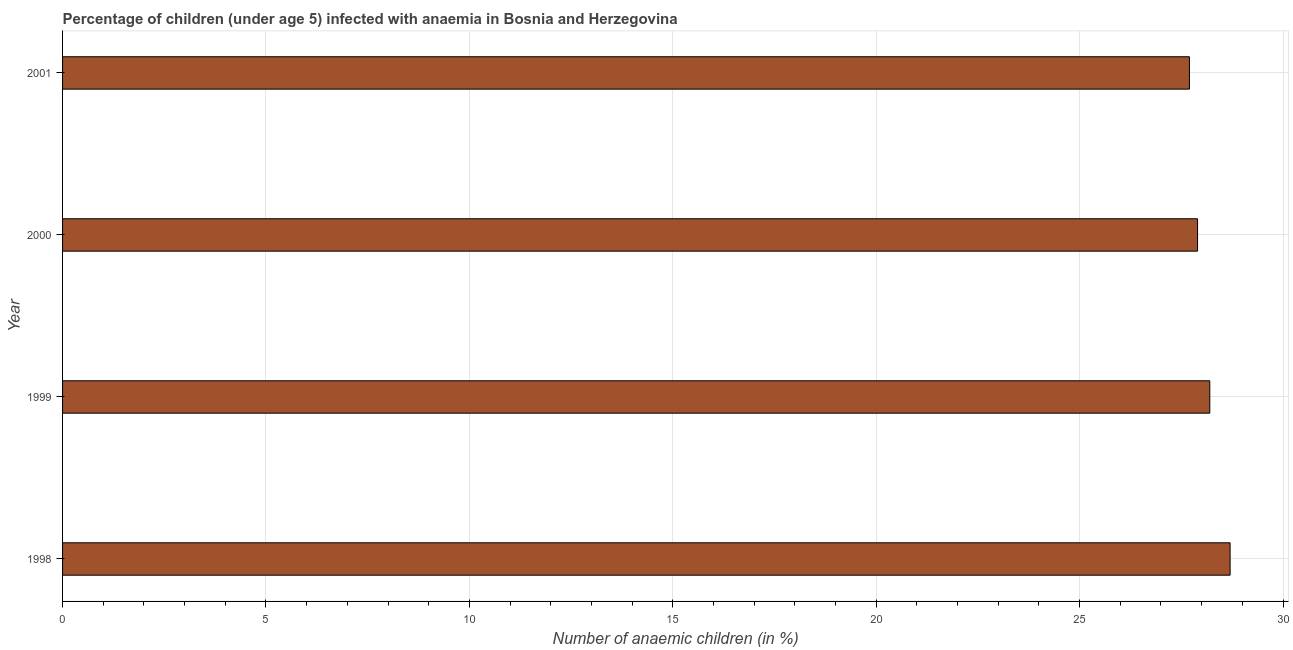What is the title of the graph?
Provide a short and direct response. Percentage of children (under age 5) infected with anaemia in Bosnia and Herzegovina. What is the label or title of the X-axis?
Your response must be concise. Number of anaemic children (in %). What is the number of anaemic children in 2001?
Keep it short and to the point. 27.7. Across all years, what is the maximum number of anaemic children?
Offer a terse response. 28.7. Across all years, what is the minimum number of anaemic children?
Give a very brief answer. 27.7. In which year was the number of anaemic children maximum?
Your response must be concise. 1998. What is the sum of the number of anaemic children?
Provide a succinct answer. 112.5. What is the difference between the number of anaemic children in 1998 and 2000?
Give a very brief answer. 0.8. What is the average number of anaemic children per year?
Your answer should be very brief. 28.12. What is the median number of anaemic children?
Your answer should be compact. 28.05. In how many years, is the number of anaemic children greater than 9 %?
Make the answer very short. 4. What is the ratio of the number of anaemic children in 1999 to that in 2000?
Your response must be concise. 1.01. What is the difference between the highest and the second highest number of anaemic children?
Offer a very short reply. 0.5. In how many years, is the number of anaemic children greater than the average number of anaemic children taken over all years?
Make the answer very short. 2. Are all the bars in the graph horizontal?
Your response must be concise. Yes. How many years are there in the graph?
Your response must be concise. 4. What is the Number of anaemic children (in %) of 1998?
Keep it short and to the point. 28.7. What is the Number of anaemic children (in %) in 1999?
Provide a succinct answer. 28.2. What is the Number of anaemic children (in %) of 2000?
Provide a short and direct response. 27.9. What is the Number of anaemic children (in %) in 2001?
Provide a succinct answer. 27.7. What is the difference between the Number of anaemic children (in %) in 1998 and 1999?
Your answer should be compact. 0.5. What is the difference between the Number of anaemic children (in %) in 1998 and 2001?
Provide a succinct answer. 1. What is the difference between the Number of anaemic children (in %) in 2000 and 2001?
Offer a terse response. 0.2. What is the ratio of the Number of anaemic children (in %) in 1998 to that in 1999?
Provide a short and direct response. 1.02. What is the ratio of the Number of anaemic children (in %) in 1998 to that in 2000?
Offer a terse response. 1.03. What is the ratio of the Number of anaemic children (in %) in 1998 to that in 2001?
Offer a terse response. 1.04. What is the ratio of the Number of anaemic children (in %) in 1999 to that in 2000?
Provide a short and direct response. 1.01. What is the ratio of the Number of anaemic children (in %) in 1999 to that in 2001?
Your answer should be compact. 1.02. 